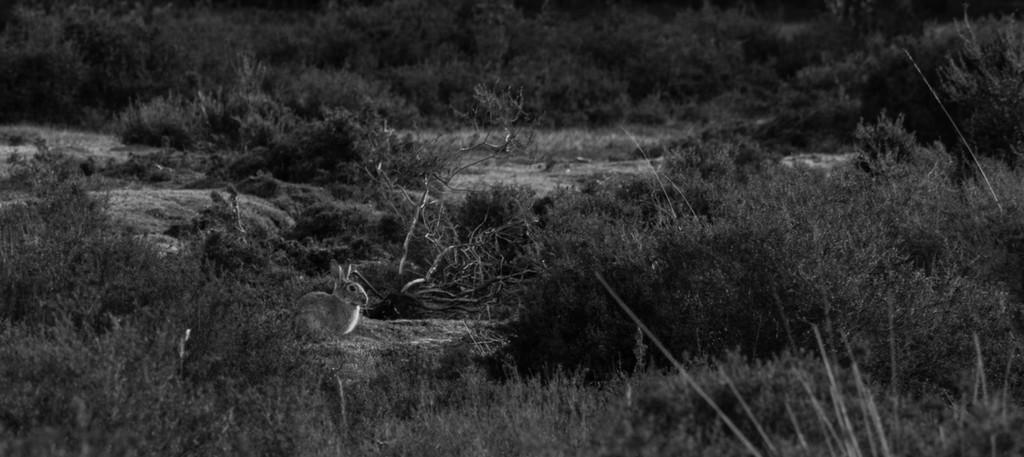What animal is present in the image? There is a rabbit in the image. What type of natural environment can be seen in the image? Trees are visible in the image. What type of cloth is being used to cover the books in the library in the image? There is no library or books present in the image, and therefore no cloth covering them. 